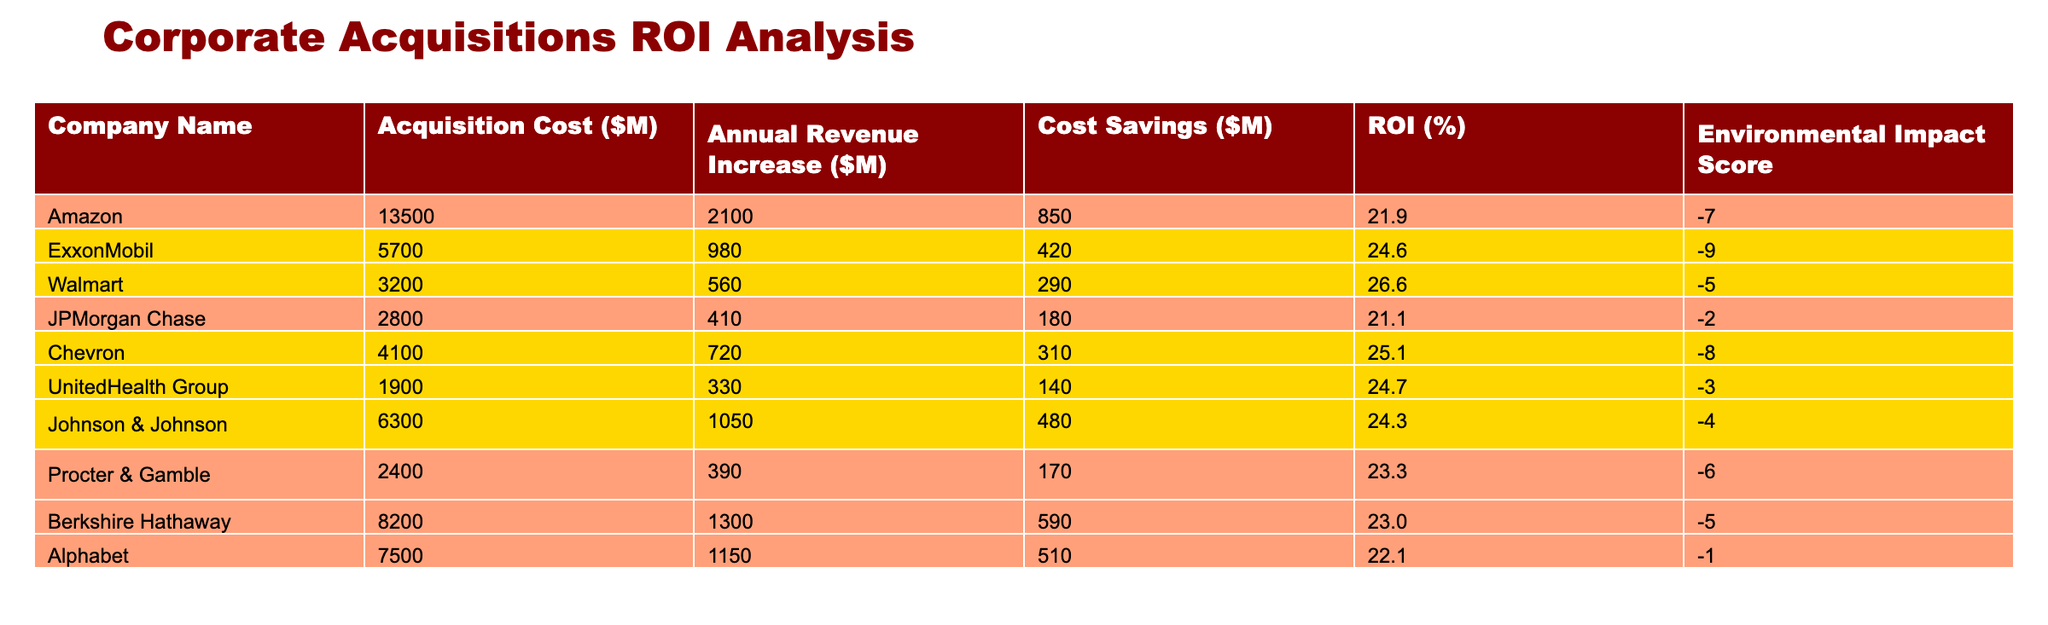What's the ROI percentage of Walmart? According to the table, Walmart has an ROI of 26.6%. This value is specifically listed in the "ROI (%)" column next to Walmart's name.
Answer: 26.6% Which acquisition had the highest Annual Revenue Increase? The Annual Revenue Increase figures show that Amazon had the highest value at 2100 million dollars. This can be found in the "Annual Revenue Increase ($M)" column.
Answer: Amazon What is the average ROI of the companies listed? To find the average ROI, sum the ROI percentages: 21.9 + 24.6 + 26.6 + 21.1 + 25.1 + 24.7 + 24.3 + 23.3 + 23.0 + 22.1 =  243.5. Then, divide by the number of companies, which is 10. Thus, 243.5/10 = 24.35%.
Answer: 24.35% Did any company have a positive Environmental Impact Score? Looking at the Environmental Impact Score column, all the companies listed have negative scores, indicating they all had a negative environmental impact.
Answer: No Which company had the lowest Cost Savings and what was it? By observing the "Cost Savings ($M)" column, we can deduce that UnitedHealth Group had the lowest cost savings of 140 million dollars. This is the smallest value in the respective column.
Answer: UnitedHealth Group, 140 What is the total Acquisition Cost of the listed companies? To find the total Acquisition Cost, sum the values in the "Acquisition Cost ($M)" column: 13500 + 5700 + 3200 + 2800 + 4100 + 1900 + 6300 + 2400 + 8200 + 7500 = 39100 million dollars.
Answer: 39100 Is Chevron's ROI higher than Alphabet's? Upon examining the ROI values, Chevron has an ROI of 25.1%, while Alphabet has an ROI of 22.1%. Therefore, Chevron's ROI is indeed higher than Alphabet's.
Answer: Yes What is the difference in ROI between ExxonMobil and Johnson & Johnson? ExxonMobil's ROI is 24.6%, and Johnson & Johnson's ROI is 24.3%. The difference is calculated as 24.6 - 24.3 = 0.3%.
Answer: 0.3% 